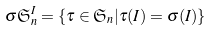<formula> <loc_0><loc_0><loc_500><loc_500>\sigma \mathfrak { S } _ { n } ^ { I } & = \{ \tau \in \mathfrak { S } _ { n } | \tau ( I ) = \sigma ( I ) \}</formula> 